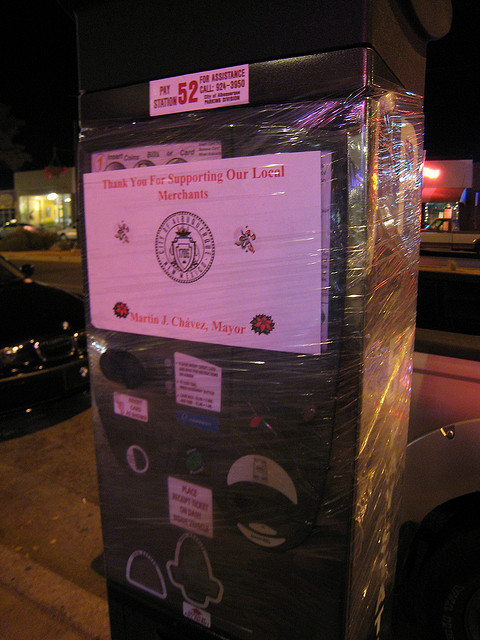Please extract the text content from this image. Thank You For Supporting Our RACE OF 924-3950 CALL ASSISTANCE FOR 52 Mayor Merchants 